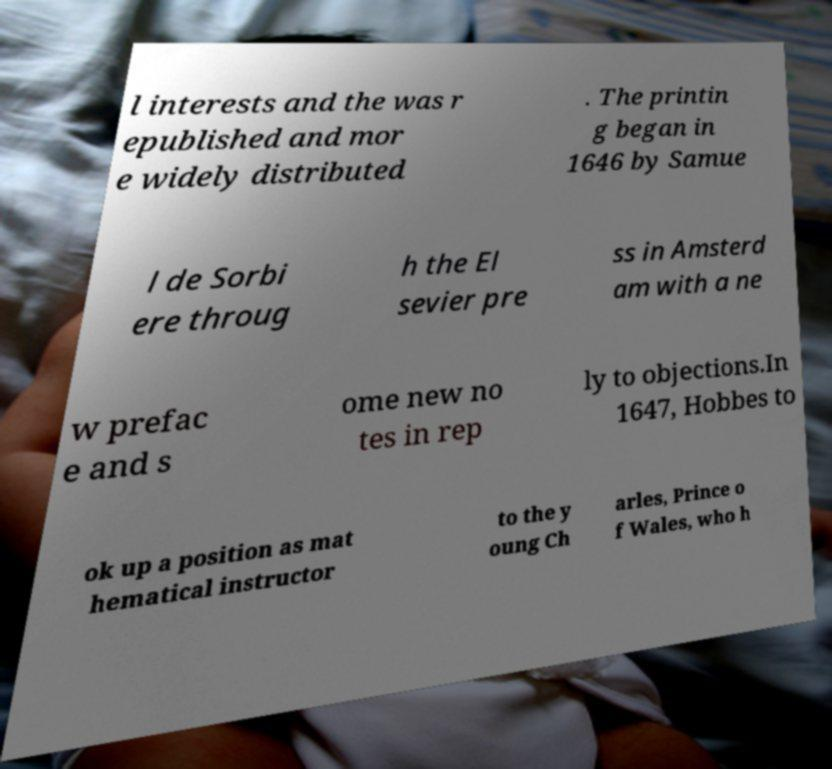I need the written content from this picture converted into text. Can you do that? l interests and the was r epublished and mor e widely distributed . The printin g began in 1646 by Samue l de Sorbi ere throug h the El sevier pre ss in Amsterd am with a ne w prefac e and s ome new no tes in rep ly to objections.In 1647, Hobbes to ok up a position as mat hematical instructor to the y oung Ch arles, Prince o f Wales, who h 